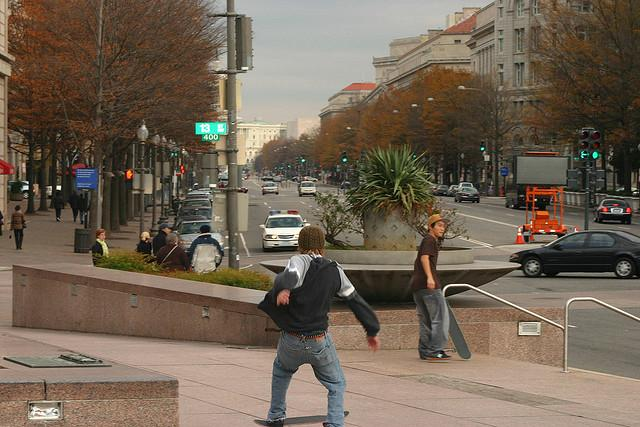Why plants are planted on roadside?

Choices:
A) decorative purpose
B) wind breaks
C) climatic excesses
D) crop prevention wind breaks 